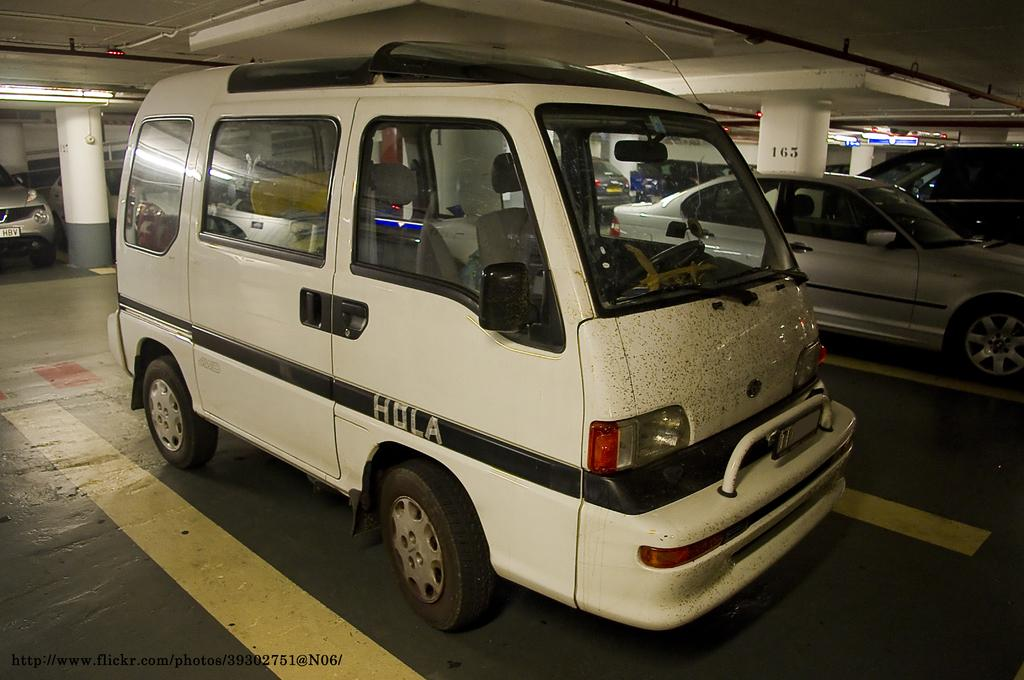What can be seen in the image? There are vehicles in the image. Where are the vehicles located? The vehicles are parked in a parking area. What is visible above the vehicles in the image? There is a ceiling visible at the top of the image. What is the interest rate for the family in the image? There is no information about interest rates or a family in the image; it only shows vehicles parked in a parking area. 